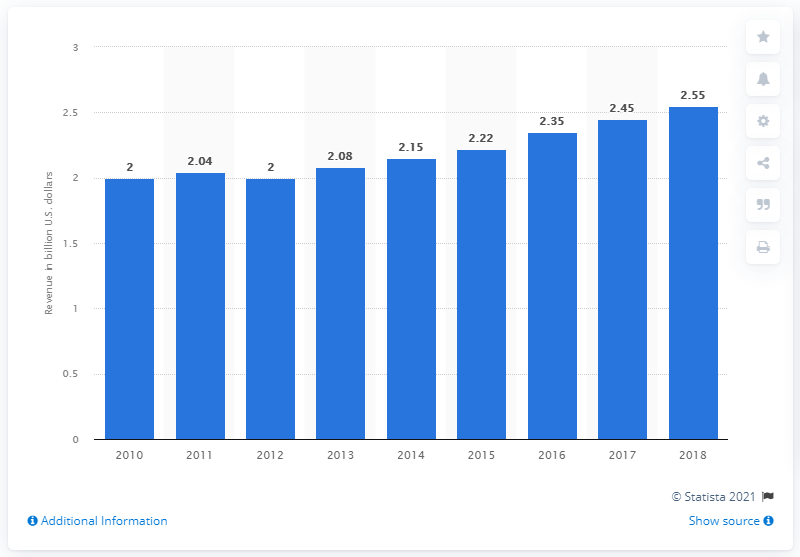Mention a couple of crucial points in this snapshot. The previous year's revenue for Travelport was 2.45... In 2018, Travelport generated approximately 2.55 billion in revenue. 